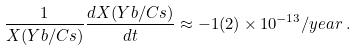<formula> <loc_0><loc_0><loc_500><loc_500>\frac { 1 } { X ( Y b / C s ) } \frac { d X ( Y b / C s ) } { d t } \approx - 1 ( 2 ) \times 1 0 ^ { - 1 3 } / y e a r \, .</formula> 